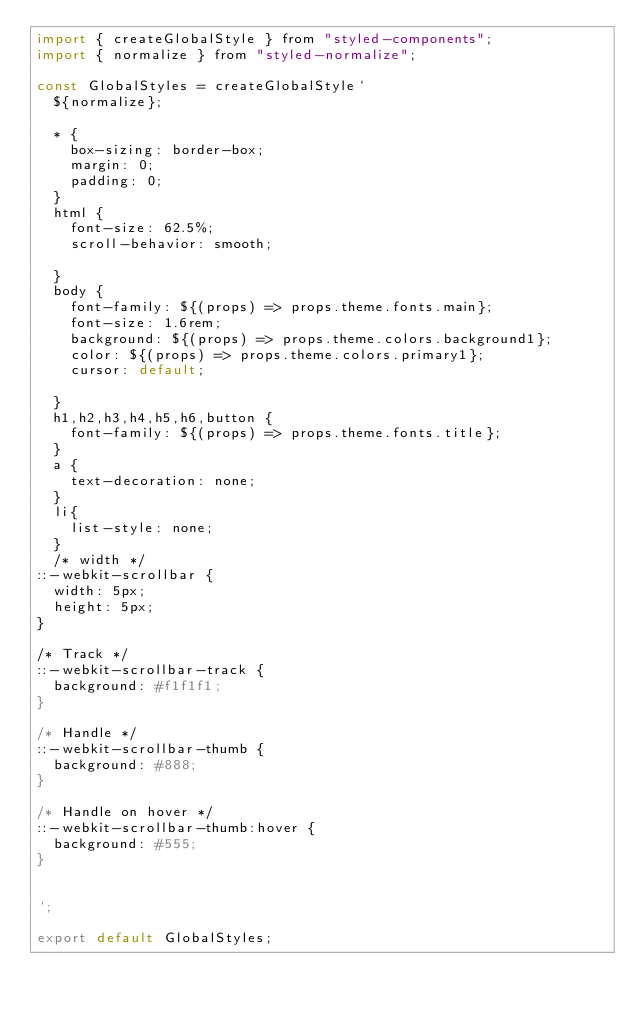<code> <loc_0><loc_0><loc_500><loc_500><_JavaScript_>import { createGlobalStyle } from "styled-components";
import { normalize } from "styled-normalize";

const GlobalStyles = createGlobalStyle`
  ${normalize};

  * {
    box-sizing: border-box;
    margin: 0;
    padding: 0;
  }
  html {
    font-size: 62.5%;
    scroll-behavior: smooth;

  }
  body {
    font-family: ${(props) => props.theme.fonts.main};
    font-size: 1.6rem;
    background: ${(props) => props.theme.colors.background1};
    color: ${(props) => props.theme.colors.primary1};
    cursor: default;

  }
  h1,h2,h3,h4,h5,h6,button {
    font-family: ${(props) => props.theme.fonts.title};
  }
  a {
    text-decoration: none;
  }
  li{
    list-style: none;
  }
  /* width */
::-webkit-scrollbar {
  width: 5px;
  height: 5px;
}

/* Track */
::-webkit-scrollbar-track {
  background: #f1f1f1;
}

/* Handle */
::-webkit-scrollbar-thumb {
  background: #888;
}

/* Handle on hover */
::-webkit-scrollbar-thumb:hover {
  background: #555;
}


`;

export default GlobalStyles;
</code> 